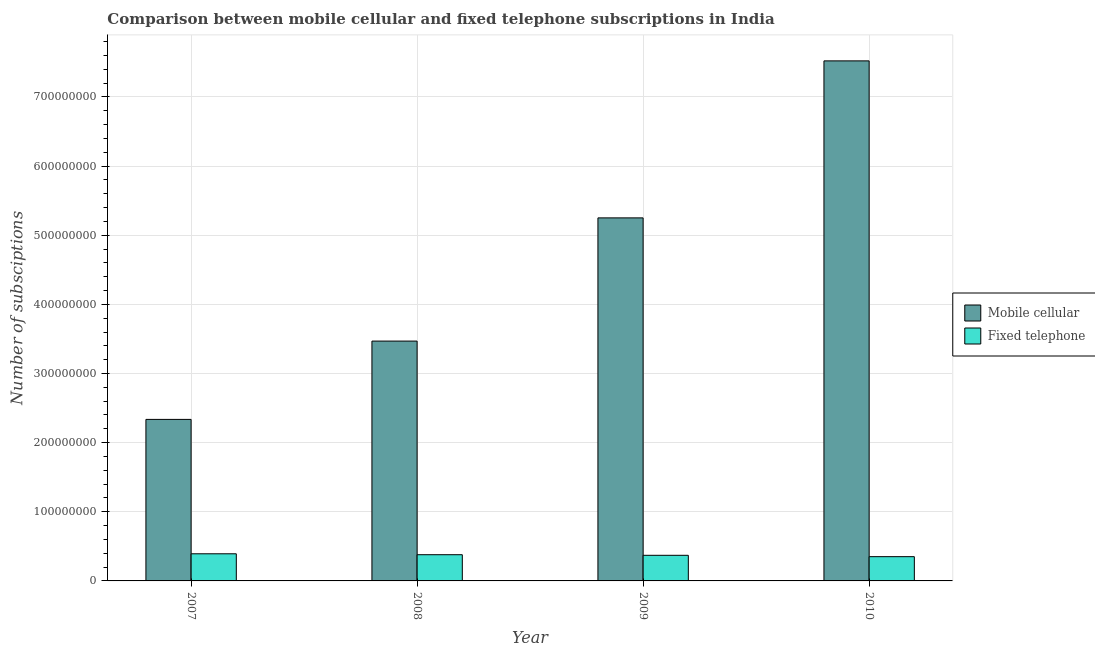Are the number of bars on each tick of the X-axis equal?
Ensure brevity in your answer.  Yes. How many bars are there on the 3rd tick from the left?
Give a very brief answer. 2. How many bars are there on the 4th tick from the right?
Make the answer very short. 2. What is the label of the 3rd group of bars from the left?
Ensure brevity in your answer.  2009. What is the number of fixed telephone subscriptions in 2008?
Give a very brief answer. 3.79e+07. Across all years, what is the maximum number of fixed telephone subscriptions?
Provide a short and direct response. 3.92e+07. Across all years, what is the minimum number of mobile cellular subscriptions?
Make the answer very short. 2.34e+08. In which year was the number of fixed telephone subscriptions maximum?
Offer a very short reply. 2007. In which year was the number of mobile cellular subscriptions minimum?
Your answer should be very brief. 2007. What is the total number of mobile cellular subscriptions in the graph?
Your answer should be compact. 1.86e+09. What is the difference between the number of fixed telephone subscriptions in 2008 and that in 2009?
Give a very brief answer. 8.40e+05. What is the difference between the number of fixed telephone subscriptions in 2010 and the number of mobile cellular subscriptions in 2007?
Provide a short and direct response. -4.16e+06. What is the average number of mobile cellular subscriptions per year?
Your answer should be very brief. 4.64e+08. In the year 2008, what is the difference between the number of mobile cellular subscriptions and number of fixed telephone subscriptions?
Your answer should be very brief. 0. What is the ratio of the number of mobile cellular subscriptions in 2009 to that in 2010?
Give a very brief answer. 0.7. Is the number of mobile cellular subscriptions in 2008 less than that in 2010?
Your response must be concise. Yes. What is the difference between the highest and the second highest number of mobile cellular subscriptions?
Keep it short and to the point. 2.27e+08. What is the difference between the highest and the lowest number of fixed telephone subscriptions?
Your response must be concise. 4.16e+06. What does the 1st bar from the left in 2009 represents?
Make the answer very short. Mobile cellular. What does the 1st bar from the right in 2007 represents?
Provide a short and direct response. Fixed telephone. How many bars are there?
Offer a very short reply. 8. Are all the bars in the graph horizontal?
Provide a succinct answer. No. What is the difference between two consecutive major ticks on the Y-axis?
Give a very brief answer. 1.00e+08. How many legend labels are there?
Your answer should be compact. 2. How are the legend labels stacked?
Your response must be concise. Vertical. What is the title of the graph?
Provide a succinct answer. Comparison between mobile cellular and fixed telephone subscriptions in India. What is the label or title of the X-axis?
Your answer should be very brief. Year. What is the label or title of the Y-axis?
Offer a terse response. Number of subsciptions. What is the Number of subsciptions in Mobile cellular in 2007?
Offer a very short reply. 2.34e+08. What is the Number of subsciptions in Fixed telephone in 2007?
Ensure brevity in your answer.  3.92e+07. What is the Number of subsciptions in Mobile cellular in 2008?
Offer a very short reply. 3.47e+08. What is the Number of subsciptions in Fixed telephone in 2008?
Make the answer very short. 3.79e+07. What is the Number of subsciptions in Mobile cellular in 2009?
Offer a very short reply. 5.25e+08. What is the Number of subsciptions of Fixed telephone in 2009?
Your answer should be very brief. 3.71e+07. What is the Number of subsciptions in Mobile cellular in 2010?
Your response must be concise. 7.52e+08. What is the Number of subsciptions in Fixed telephone in 2010?
Your answer should be compact. 3.51e+07. Across all years, what is the maximum Number of subsciptions of Mobile cellular?
Your answer should be compact. 7.52e+08. Across all years, what is the maximum Number of subsciptions in Fixed telephone?
Give a very brief answer. 3.92e+07. Across all years, what is the minimum Number of subsciptions in Mobile cellular?
Your answer should be very brief. 2.34e+08. Across all years, what is the minimum Number of subsciptions in Fixed telephone?
Offer a terse response. 3.51e+07. What is the total Number of subsciptions in Mobile cellular in the graph?
Give a very brief answer. 1.86e+09. What is the total Number of subsciptions in Fixed telephone in the graph?
Provide a short and direct response. 1.49e+08. What is the difference between the Number of subsciptions of Mobile cellular in 2007 and that in 2008?
Give a very brief answer. -1.13e+08. What is the difference between the Number of subsciptions of Fixed telephone in 2007 and that in 2008?
Your answer should be very brief. 1.35e+06. What is the difference between the Number of subsciptions of Mobile cellular in 2007 and that in 2009?
Offer a very short reply. -2.91e+08. What is the difference between the Number of subsciptions in Fixed telephone in 2007 and that in 2009?
Provide a succinct answer. 2.19e+06. What is the difference between the Number of subsciptions of Mobile cellular in 2007 and that in 2010?
Ensure brevity in your answer.  -5.19e+08. What is the difference between the Number of subsciptions of Fixed telephone in 2007 and that in 2010?
Make the answer very short. 4.16e+06. What is the difference between the Number of subsciptions in Mobile cellular in 2008 and that in 2009?
Offer a terse response. -1.78e+08. What is the difference between the Number of subsciptions in Fixed telephone in 2008 and that in 2009?
Keep it short and to the point. 8.40e+05. What is the difference between the Number of subsciptions in Mobile cellular in 2008 and that in 2010?
Provide a short and direct response. -4.05e+08. What is the difference between the Number of subsciptions of Fixed telephone in 2008 and that in 2010?
Provide a short and direct response. 2.81e+06. What is the difference between the Number of subsciptions in Mobile cellular in 2009 and that in 2010?
Ensure brevity in your answer.  -2.27e+08. What is the difference between the Number of subsciptions in Fixed telephone in 2009 and that in 2010?
Provide a short and direct response. 1.97e+06. What is the difference between the Number of subsciptions in Mobile cellular in 2007 and the Number of subsciptions in Fixed telephone in 2008?
Your response must be concise. 1.96e+08. What is the difference between the Number of subsciptions in Mobile cellular in 2007 and the Number of subsciptions in Fixed telephone in 2009?
Keep it short and to the point. 1.97e+08. What is the difference between the Number of subsciptions in Mobile cellular in 2007 and the Number of subsciptions in Fixed telephone in 2010?
Keep it short and to the point. 1.99e+08. What is the difference between the Number of subsciptions in Mobile cellular in 2008 and the Number of subsciptions in Fixed telephone in 2009?
Your answer should be compact. 3.10e+08. What is the difference between the Number of subsciptions of Mobile cellular in 2008 and the Number of subsciptions of Fixed telephone in 2010?
Your answer should be compact. 3.12e+08. What is the difference between the Number of subsciptions of Mobile cellular in 2009 and the Number of subsciptions of Fixed telephone in 2010?
Keep it short and to the point. 4.90e+08. What is the average Number of subsciptions of Mobile cellular per year?
Offer a terse response. 4.64e+08. What is the average Number of subsciptions in Fixed telephone per year?
Offer a terse response. 3.73e+07. In the year 2007, what is the difference between the Number of subsciptions in Mobile cellular and Number of subsciptions in Fixed telephone?
Your answer should be compact. 1.94e+08. In the year 2008, what is the difference between the Number of subsciptions of Mobile cellular and Number of subsciptions of Fixed telephone?
Your response must be concise. 3.09e+08. In the year 2009, what is the difference between the Number of subsciptions of Mobile cellular and Number of subsciptions of Fixed telephone?
Keep it short and to the point. 4.88e+08. In the year 2010, what is the difference between the Number of subsciptions of Mobile cellular and Number of subsciptions of Fixed telephone?
Provide a short and direct response. 7.17e+08. What is the ratio of the Number of subsciptions of Mobile cellular in 2007 to that in 2008?
Offer a very short reply. 0.67. What is the ratio of the Number of subsciptions of Fixed telephone in 2007 to that in 2008?
Your answer should be compact. 1.04. What is the ratio of the Number of subsciptions of Mobile cellular in 2007 to that in 2009?
Your answer should be very brief. 0.44. What is the ratio of the Number of subsciptions in Fixed telephone in 2007 to that in 2009?
Offer a terse response. 1.06. What is the ratio of the Number of subsciptions of Mobile cellular in 2007 to that in 2010?
Provide a short and direct response. 0.31. What is the ratio of the Number of subsciptions of Fixed telephone in 2007 to that in 2010?
Provide a succinct answer. 1.12. What is the ratio of the Number of subsciptions in Mobile cellular in 2008 to that in 2009?
Offer a terse response. 0.66. What is the ratio of the Number of subsciptions of Fixed telephone in 2008 to that in 2009?
Ensure brevity in your answer.  1.02. What is the ratio of the Number of subsciptions in Mobile cellular in 2008 to that in 2010?
Offer a terse response. 0.46. What is the ratio of the Number of subsciptions in Fixed telephone in 2008 to that in 2010?
Offer a very short reply. 1.08. What is the ratio of the Number of subsciptions in Mobile cellular in 2009 to that in 2010?
Give a very brief answer. 0.7. What is the ratio of the Number of subsciptions of Fixed telephone in 2009 to that in 2010?
Offer a terse response. 1.06. What is the difference between the highest and the second highest Number of subsciptions in Mobile cellular?
Give a very brief answer. 2.27e+08. What is the difference between the highest and the second highest Number of subsciptions in Fixed telephone?
Your answer should be very brief. 1.35e+06. What is the difference between the highest and the lowest Number of subsciptions of Mobile cellular?
Offer a very short reply. 5.19e+08. What is the difference between the highest and the lowest Number of subsciptions in Fixed telephone?
Your response must be concise. 4.16e+06. 